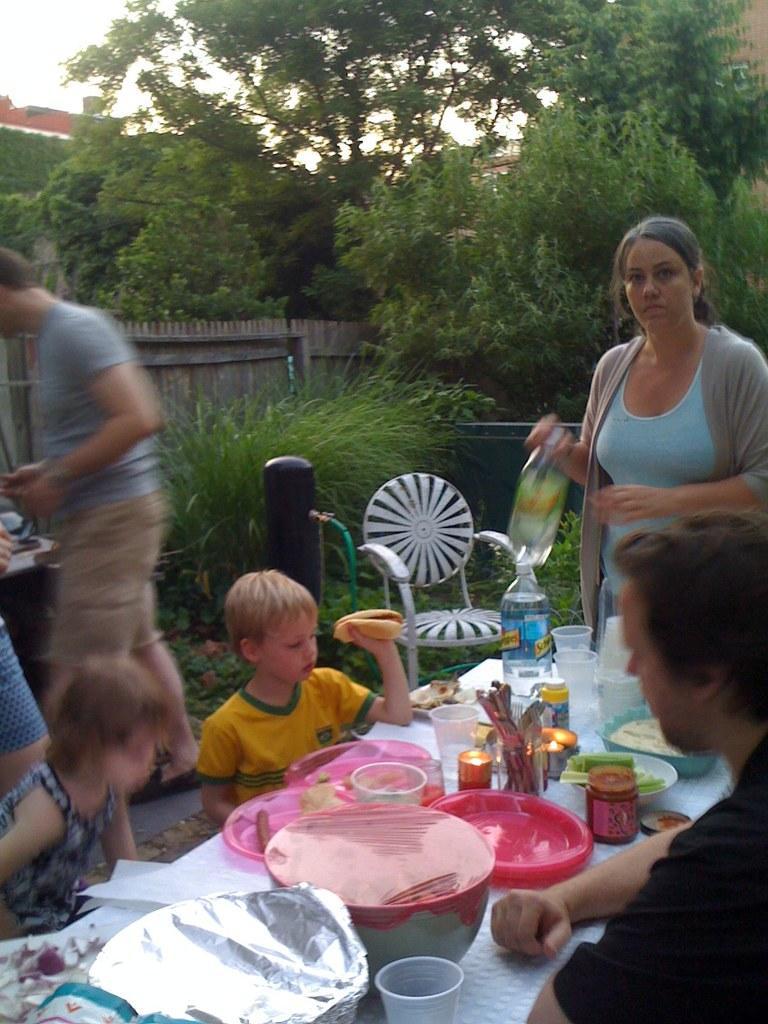In one or two sentences, can you explain what this image depicts? This picture shows few people seated on the chairs and couple of them are standing and we see bowls ,plates ,bottles and glasses on the table and we see few trees 